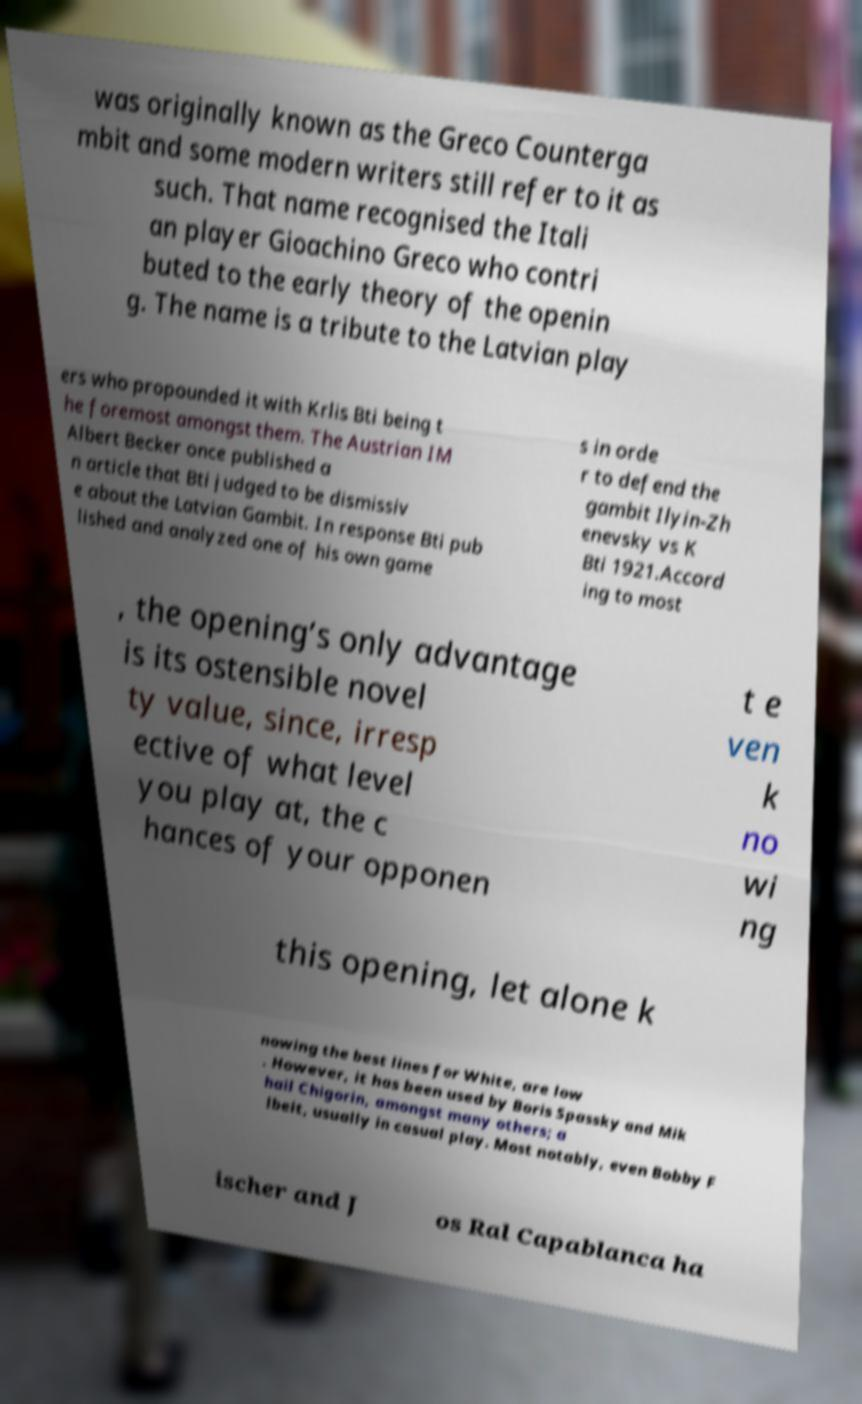Please read and relay the text visible in this image. What does it say? was originally known as the Greco Counterga mbit and some modern writers still refer to it as such. That name recognised the Itali an player Gioachino Greco who contri buted to the early theory of the openin g. The name is a tribute to the Latvian play ers who propounded it with Krlis Bti being t he foremost amongst them. The Austrian IM Albert Becker once published a n article that Bti judged to be dismissiv e about the Latvian Gambit. In response Bti pub lished and analyzed one of his own game s in orde r to defend the gambit Ilyin-Zh enevsky vs K Bti 1921.Accord ing to most , the opening’s only advantage is its ostensible novel ty value, since, irresp ective of what level you play at, the c hances of your opponen t e ven k no wi ng this opening, let alone k nowing the best lines for White, are low . However, it has been used by Boris Spassky and Mik hail Chigorin, amongst many others; a lbeit, usually in casual play. Most notably, even Bobby F ischer and J os Ral Capablanca ha 